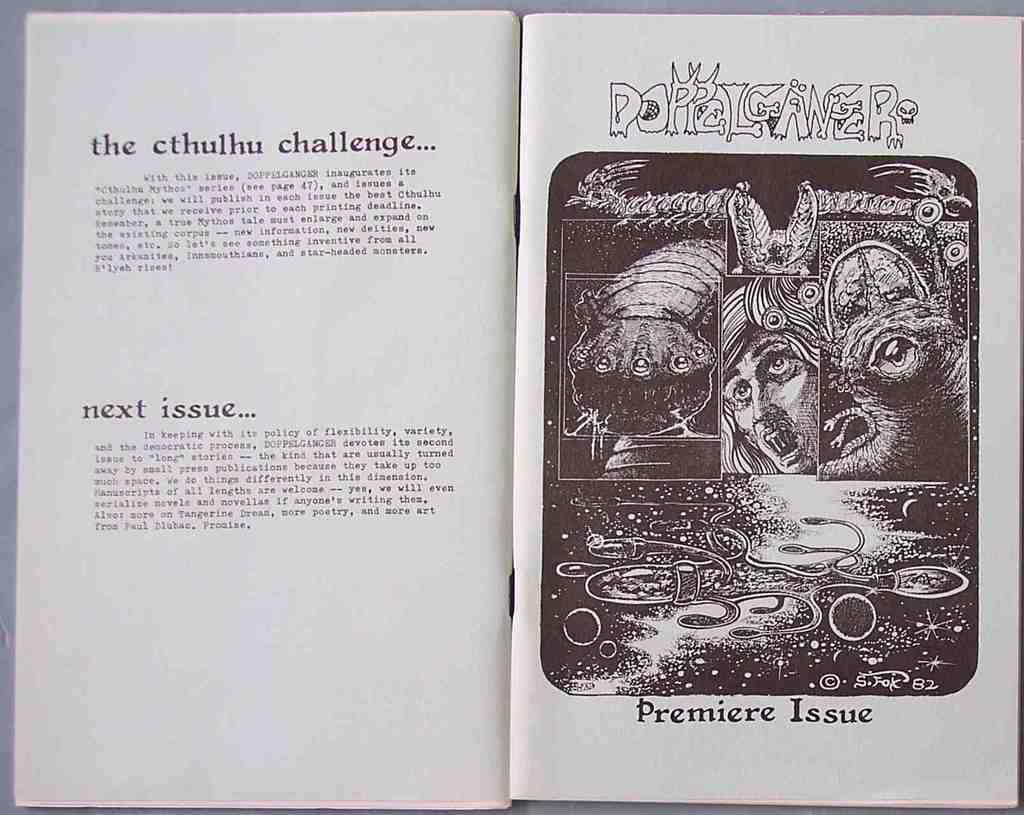<image>
Describe the image concisely. A book is open with a picture and the designation of premiere issue below it. 